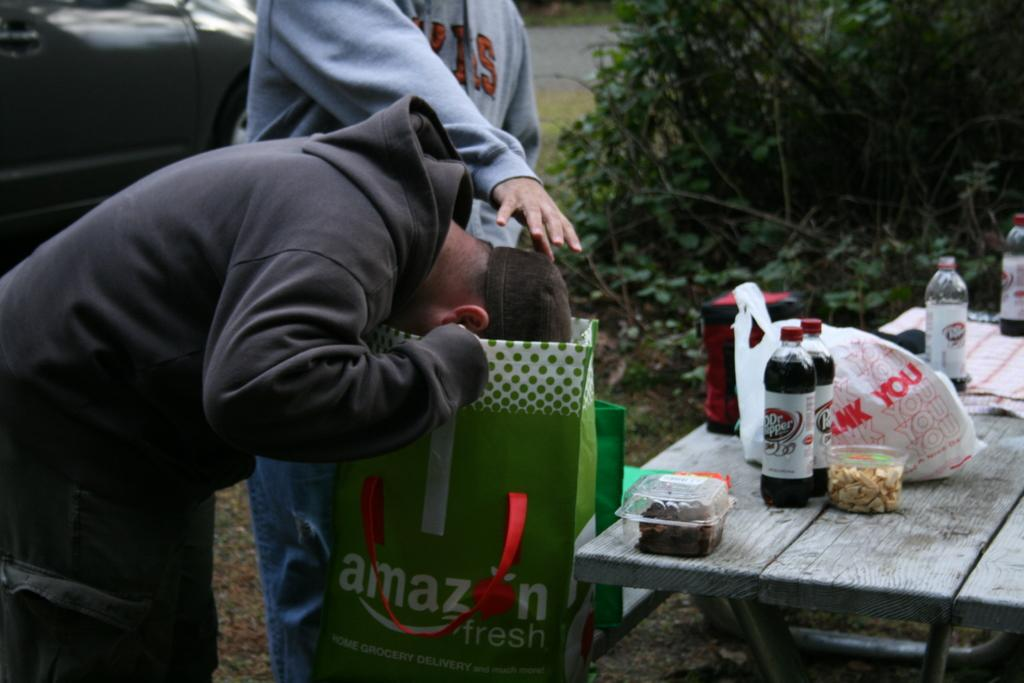How many people are in the image? There are two persons in the image. What are the two persons doing in the image? The two persons are standing in front of a table. What can be seen on the table in the image? There are different items on the table. What else is present in the image besides the two persons and the table? There is a vehicle in the image. What type of fish can be seen swimming in the pocket of one of the persons in the image? There is no fish present in the image, nor is there any mention of a pocket. 